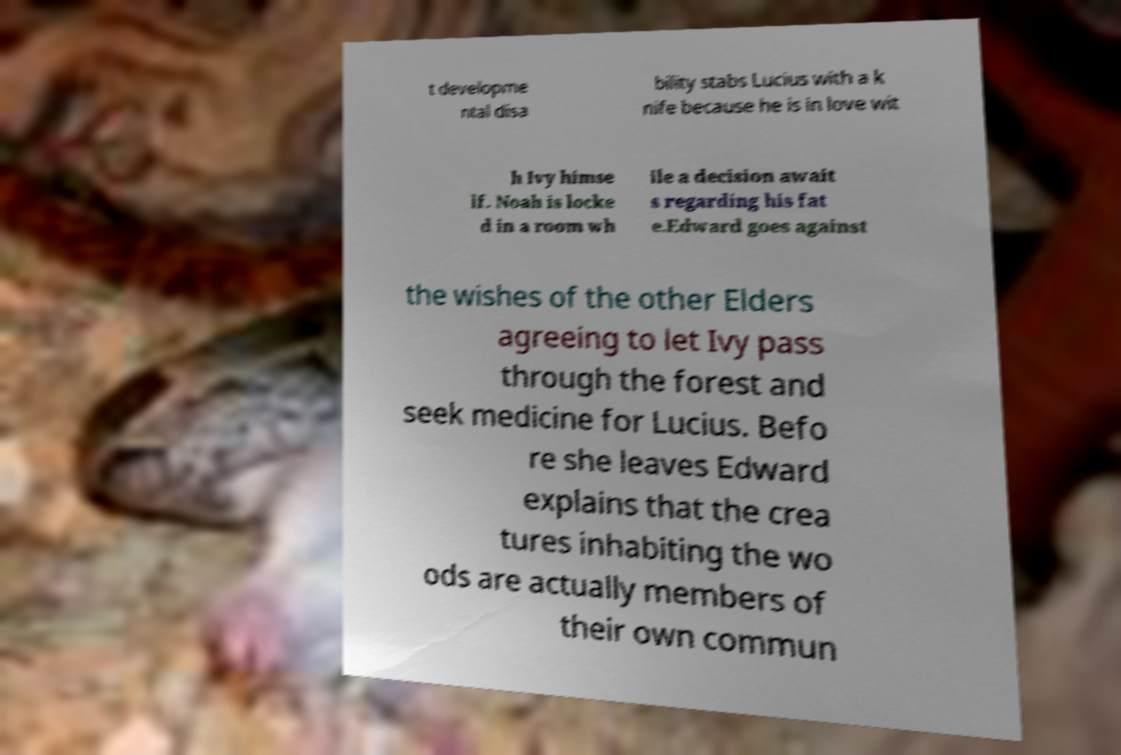Please read and relay the text visible in this image. What does it say? t developme ntal disa bility stabs Lucius with a k nife because he is in love wit h Ivy himse lf. Noah is locke d in a room wh ile a decision await s regarding his fat e.Edward goes against the wishes of the other Elders agreeing to let Ivy pass through the forest and seek medicine for Lucius. Befo re she leaves Edward explains that the crea tures inhabiting the wo ods are actually members of their own commun 